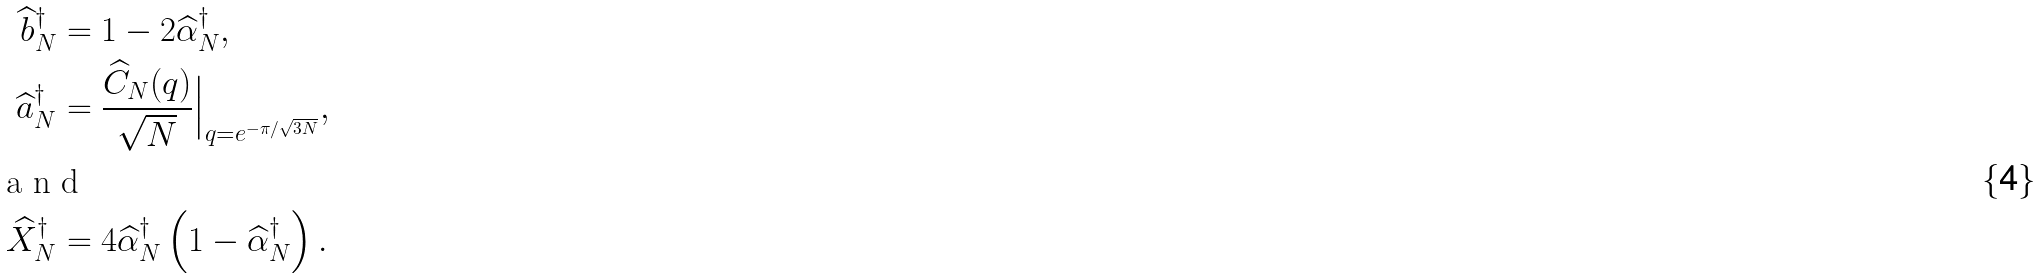<formula> <loc_0><loc_0><loc_500><loc_500>\widehat { b } ^ { \dagger } _ { N } & = 1 - 2 \widehat { \alpha } ^ { \dagger } _ { N } , \\ \widehat { a } ^ { \dagger } _ { N } & = \frac { \widehat { C } _ { N } ( q ) } { \sqrt { N } } \Big | _ { q = e ^ { - \pi / \sqrt { 3 N } } } , \\ \intertext { a n d } \widehat { X } ^ { \dagger } _ { N } & = 4 \widehat { \alpha } ^ { \dagger } _ { N } \left ( 1 - \widehat { \alpha } ^ { \dagger } _ { N } \right ) .</formula> 